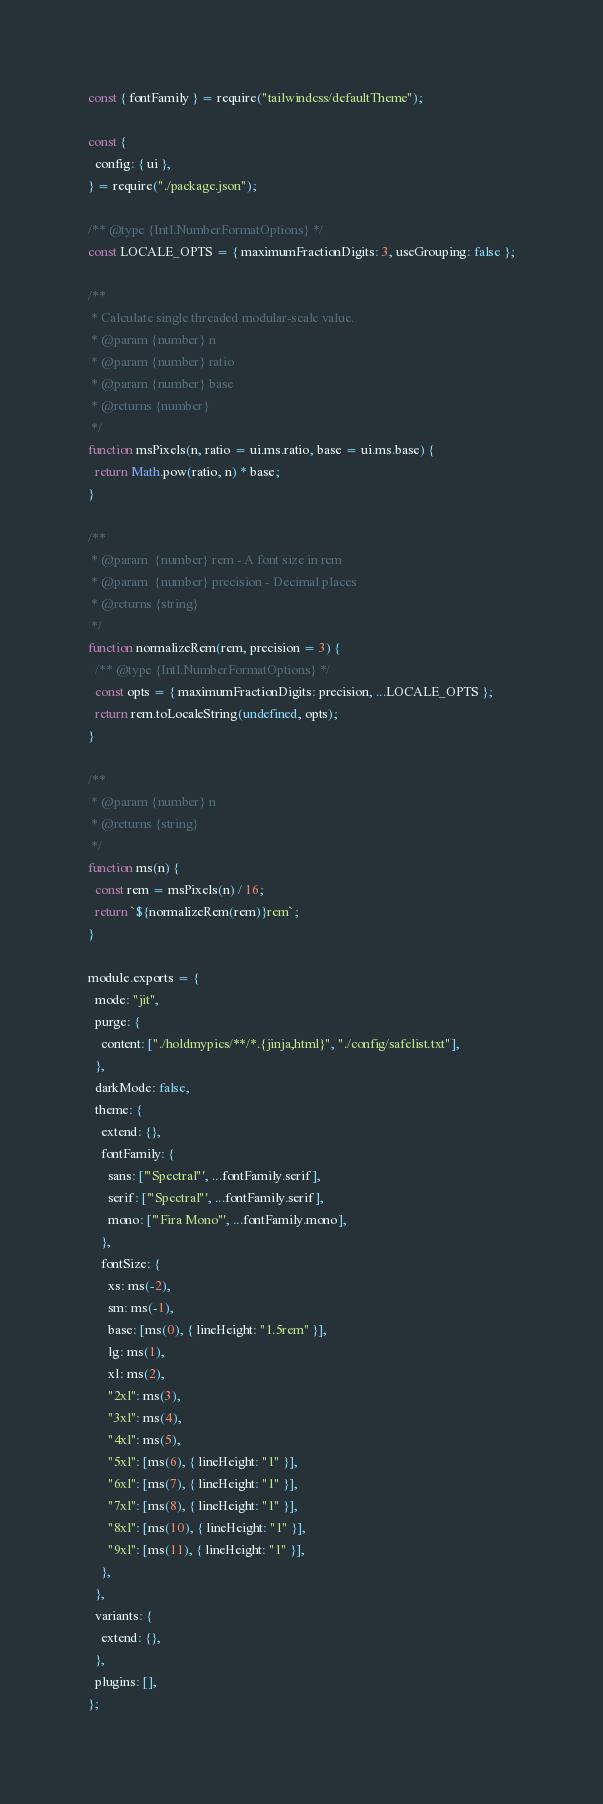Convert code to text. <code><loc_0><loc_0><loc_500><loc_500><_JavaScript_>const { fontFamily } = require("tailwindcss/defaultTheme");

const {
  config: { ui },
} = require("./package.json");

/** @type {Intl.NumberFormatOptions} */
const LOCALE_OPTS = { maximumFractionDigits: 3, useGrouping: false };

/**
 * Calculate single threaded modular-scale value.
 * @param {number} n
 * @param {number} ratio
 * @param {number} base
 * @returns {number}
 */
function msPixels(n, ratio = ui.ms.ratio, base = ui.ms.base) {
  return Math.pow(ratio, n) * base;
}

/**
 * @param  {number} rem - A font size in rem
 * @param  {number} precision - Decimal places
 * @returns {string}
 */
function normalizeRem(rem, precision = 3) {
  /** @type {Intl.NumberFormatOptions} */
  const opts = { maximumFractionDigits: precision, ...LOCALE_OPTS };
  return rem.toLocaleString(undefined, opts);
}

/**
 * @param {number} n
 * @returns {string}
 */
function ms(n) {
  const rem = msPixels(n) / 16;
  return `${normalizeRem(rem)}rem`;
}

module.exports = {
  mode: "jit",
  purge: {
    content: ["./holdmypics/**/*.{jinja,html}", "./config/safelist.txt"],
  },
  darkMode: false,
  theme: {
    extend: {},
    fontFamily: {
      sans: ['"Spectral"', ...fontFamily.serif],
      serif: ['"Spectral"', ...fontFamily.serif],
      mono: ['"Fira Mono"', ...fontFamily.mono],
    },
    fontSize: {
      xs: ms(-2),
      sm: ms(-1),
      base: [ms(0), { lineHeight: "1.5rem" }],
      lg: ms(1),
      xl: ms(2),
      "2xl": ms(3),
      "3xl": ms(4),
      "4xl": ms(5),
      "5xl": [ms(6), { lineHeight: "1" }],
      "6xl": [ms(7), { lineHeight: "1" }],
      "7xl": [ms(8), { lineHeight: "1" }],
      "8xl": [ms(10), { lineHeight: "1" }],
      "9xl": [ms(11), { lineHeight: "1" }],
    },
  },
  variants: {
    extend: {},
  },
  plugins: [],
};
</code> 